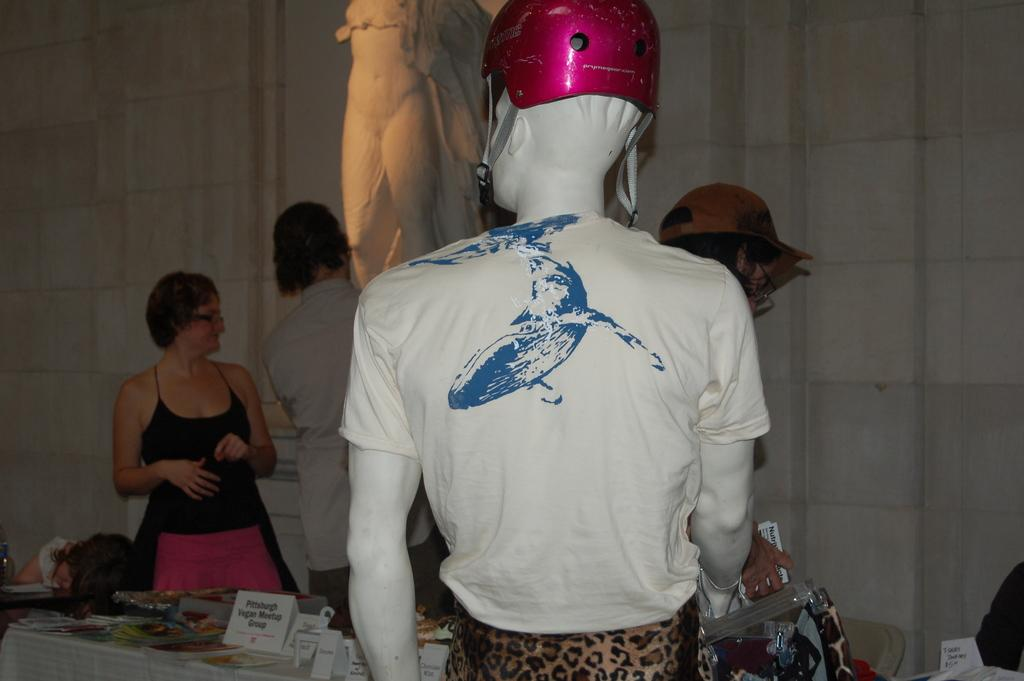What is happening in the image? There are people standing in the image. Can you describe the arrangement of the chair in the image? There is a chair arranged in the image. What is placed on the chair? Objects are placed on the chair. What other notable object or figure is present in the image? There is a mannequin in the image. What type of bun is the mannequin wearing in the image? There is no bun present in the image, as the mannequin is not wearing any clothing or accessories. Can you hear the people in the image laughing? The image is a still picture, so we cannot hear any sounds or laughter. 